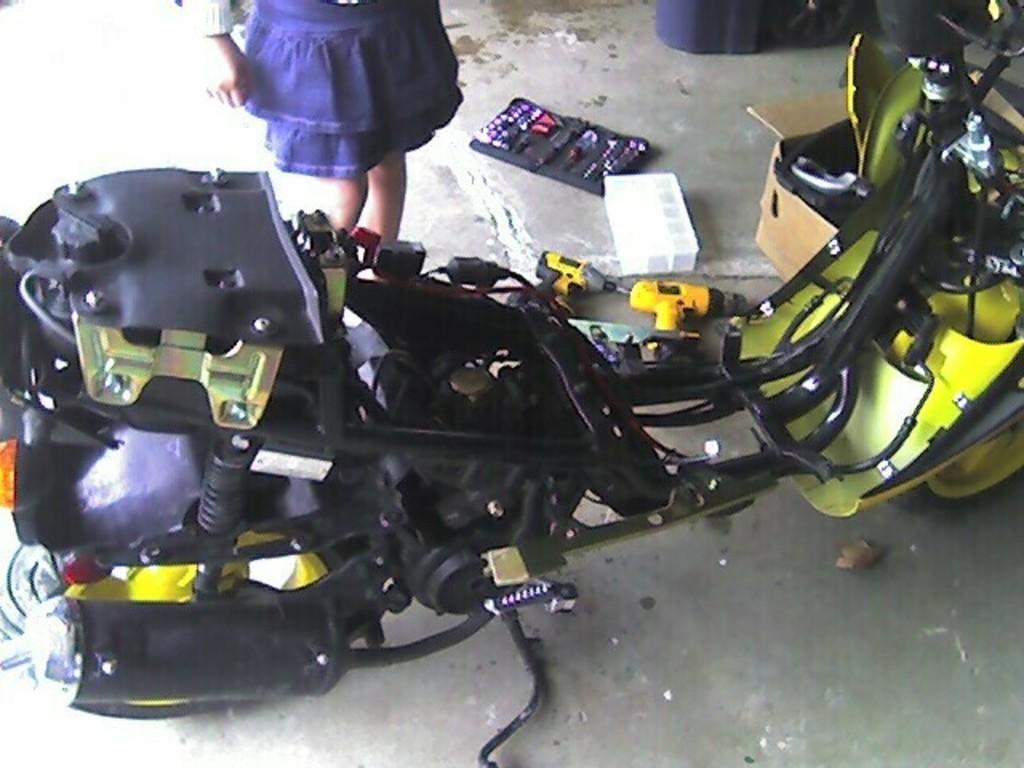What vehicle is on the ground in the image? There is a motorcycle on the ground in the image. Can you describe the scene in the background of the image? In the background of the image, there is a person, a box, a device, and some other objects. What might the device in the background be used for? It is not clear from the image what the device in the background is used for. How many people are visible in the image? There is only one person visible in the image, and they are in the background. What type of pets are playing with the motorcycle in the image? There are no pets present in the image, and the motorcycle is stationary on the ground. 